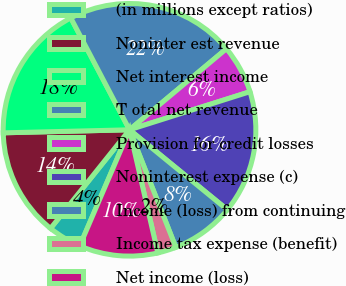Convert chart to OTSL. <chart><loc_0><loc_0><loc_500><loc_500><pie_chart><fcel>(in millions except ratios)<fcel>Noninter est revenue<fcel>Net interest income<fcel>T otal net revenue<fcel>Provision for credit losses<fcel>Noninterest expense (c)<fcel>Income (loss) from continuing<fcel>Income tax expense (benefit)<fcel>Net income (loss)<nl><fcel>4.3%<fcel>13.87%<fcel>17.69%<fcel>21.61%<fcel>6.21%<fcel>15.78%<fcel>8.12%<fcel>2.38%<fcel>10.04%<nl></chart> 